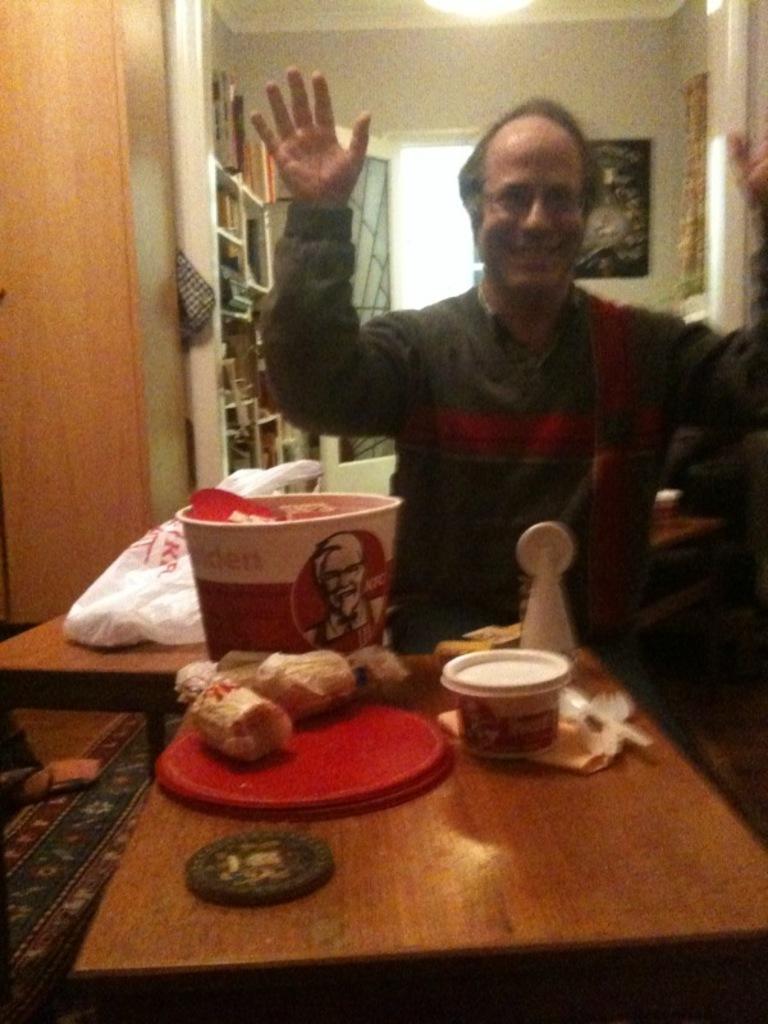Could you give a brief overview of what you see in this image? A man is sitting at a table with eatables on it. 